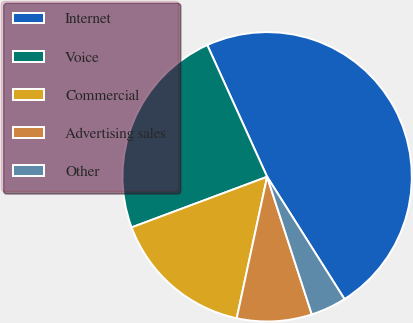Convert chart to OTSL. <chart><loc_0><loc_0><loc_500><loc_500><pie_chart><fcel>Internet<fcel>Voice<fcel>Commercial<fcel>Advertising sales<fcel>Other<nl><fcel>47.81%<fcel>23.9%<fcel>15.94%<fcel>8.37%<fcel>3.98%<nl></chart> 